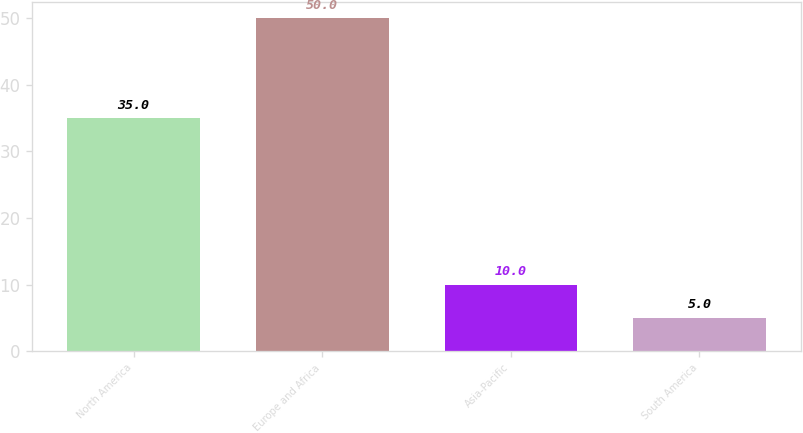Convert chart. <chart><loc_0><loc_0><loc_500><loc_500><bar_chart><fcel>North America<fcel>Europe and Africa<fcel>Asia-Pacific<fcel>South America<nl><fcel>35<fcel>50<fcel>10<fcel>5<nl></chart> 